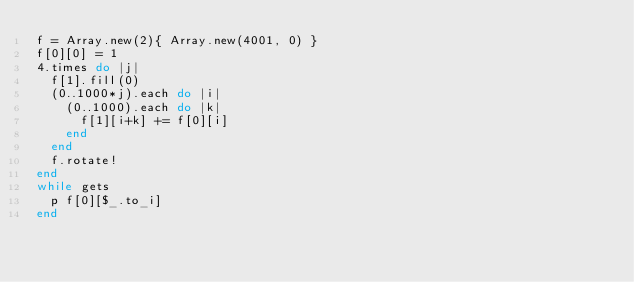<code> <loc_0><loc_0><loc_500><loc_500><_Ruby_>f = Array.new(2){ Array.new(4001, 0) }
f[0][0] = 1
4.times do |j|
  f[1].fill(0)
  (0..1000*j).each do |i|
    (0..1000).each do |k|
      f[1][i+k] += f[0][i]
    end
  end
  f.rotate!
end
while gets
  p f[0][$_.to_i]
end</code> 